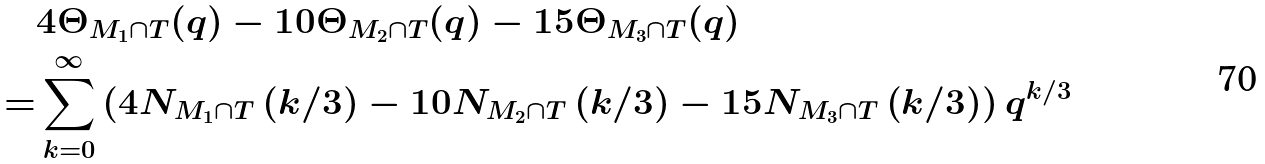Convert formula to latex. <formula><loc_0><loc_0><loc_500><loc_500>& 4 \Theta _ { M _ { 1 } \cap T } ( q ) - 1 0 \Theta _ { M _ { 2 } \cap T } ( q ) - 1 5 \Theta _ { M _ { 3 } \cap T } ( q ) \\ = & \sum _ { k = 0 } ^ { \infty } \left ( 4 N _ { M _ { 1 } \cap T } \left ( k / 3 \right ) - 1 0 N _ { M _ { 2 } \cap T } \left ( k / 3 \right ) - 1 5 N _ { M _ { 3 } \cap T } \left ( k / 3 \right ) \right ) q ^ { k / 3 }</formula> 